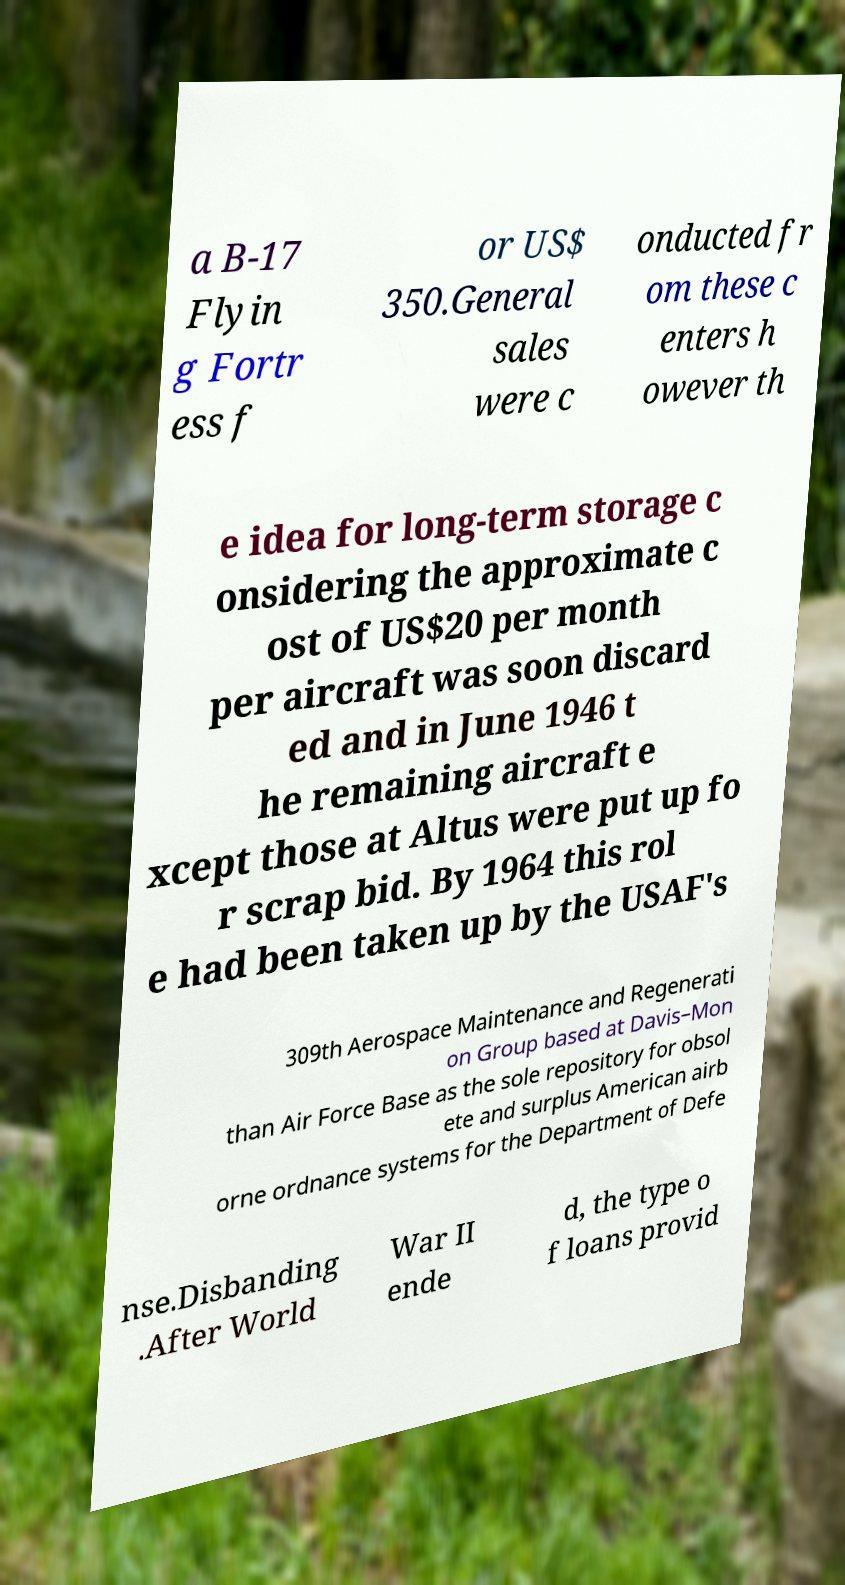There's text embedded in this image that I need extracted. Can you transcribe it verbatim? a B-17 Flyin g Fortr ess f or US$ 350.General sales were c onducted fr om these c enters h owever th e idea for long-term storage c onsidering the approximate c ost of US$20 per month per aircraft was soon discard ed and in June 1946 t he remaining aircraft e xcept those at Altus were put up fo r scrap bid. By 1964 this rol e had been taken up by the USAF's 309th Aerospace Maintenance and Regenerati on Group based at Davis–Mon than Air Force Base as the sole repository for obsol ete and surplus American airb orne ordnance systems for the Department of Defe nse.Disbanding .After World War II ende d, the type o f loans provid 